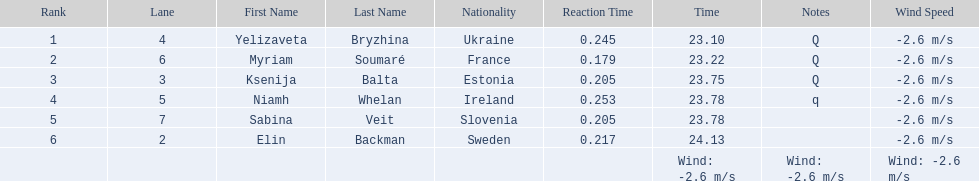What are all the names? Yelizaveta Bryzhina, Myriam Soumaré, Ksenija Balta, Niamh Whelan, Sabina Veit, Elin Backman. What were their finishing times? 23.10, 23.22, 23.75, 23.78, 23.78, 24.13. And which time was reached by ellen backman? 24.13. 